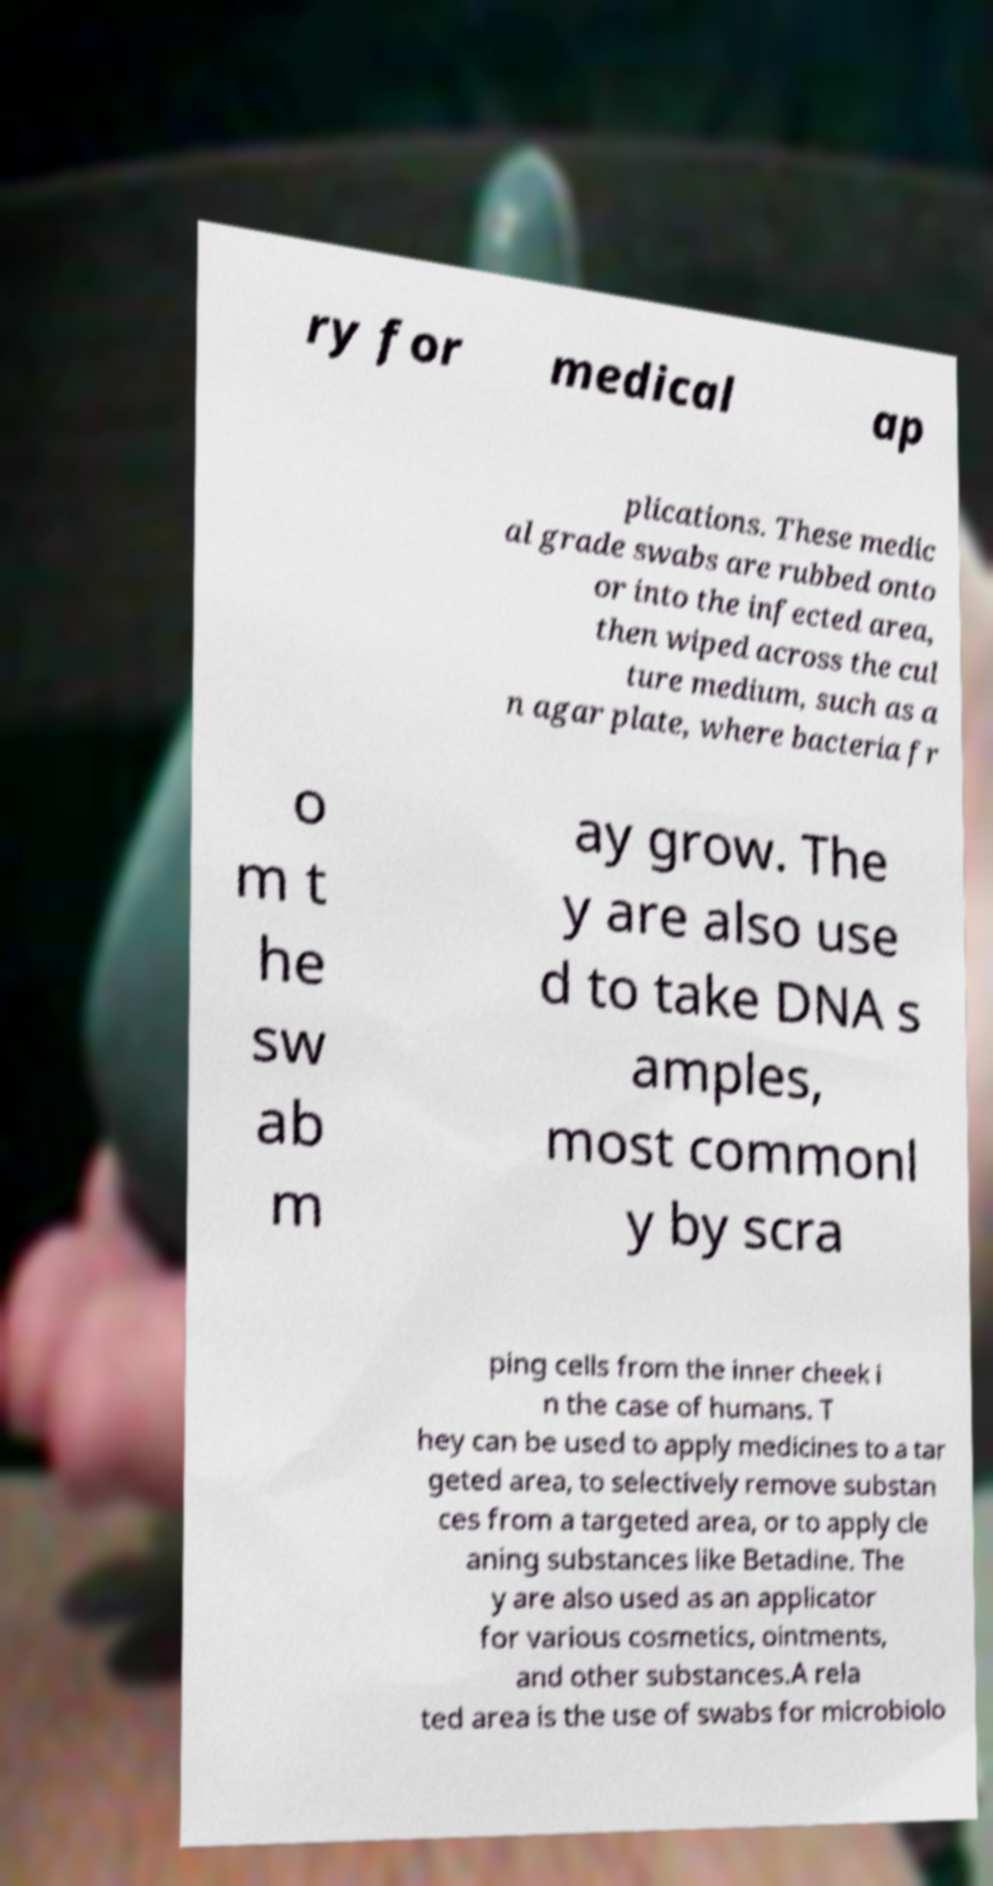I need the written content from this picture converted into text. Can you do that? ry for medical ap plications. These medic al grade swabs are rubbed onto or into the infected area, then wiped across the cul ture medium, such as a n agar plate, where bacteria fr o m t he sw ab m ay grow. The y are also use d to take DNA s amples, most commonl y by scra ping cells from the inner cheek i n the case of humans. T hey can be used to apply medicines to a tar geted area, to selectively remove substan ces from a targeted area, or to apply cle aning substances like Betadine. The y are also used as an applicator for various cosmetics, ointments, and other substances.A rela ted area is the use of swabs for microbiolo 